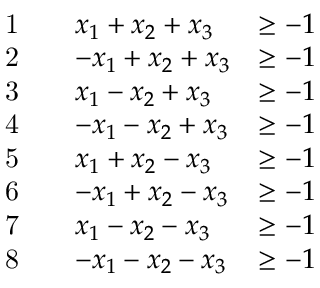Convert formula to latex. <formula><loc_0><loc_0><loc_500><loc_500>\begin{array} { r l r l r } & { 1 } & & { x _ { 1 } + x _ { 2 } + x _ { 3 } } & { \geq - 1 } \\ & { 2 } & & { - x _ { 1 } + x _ { 2 } + x _ { 3 } } & { \geq - 1 } \\ & { 3 } & & { x _ { 1 } - x _ { 2 } + x _ { 3 } } & { \geq - 1 } \\ & { 4 } & & { - x _ { 1 } - x _ { 2 } + x _ { 3 } } & { \geq - 1 } \\ & { 5 } & & { x _ { 1 } + x _ { 2 } - x _ { 3 } } & { \geq - 1 } \\ & { 6 } & & { - x _ { 1 } + x _ { 2 } - x _ { 3 } } & { \geq - 1 } \\ & { 7 } & & { x _ { 1 } - x _ { 2 } - x _ { 3 } } & { \geq - 1 } \\ & { 8 } & & { - x _ { 1 } - x _ { 2 } - x _ { 3 } } & { \geq - 1 } \end{array}</formula> 